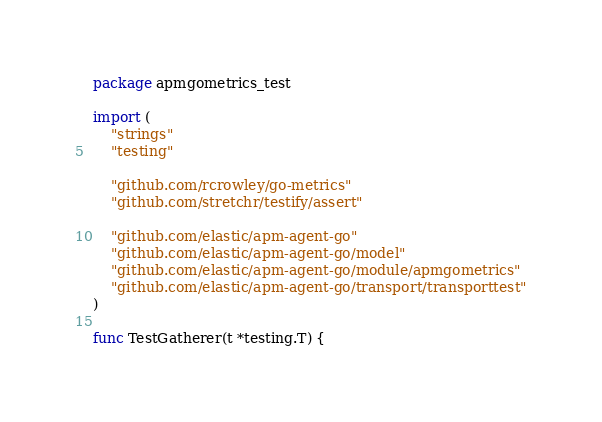Convert code to text. <code><loc_0><loc_0><loc_500><loc_500><_Go_>package apmgometrics_test

import (
	"strings"
	"testing"

	"github.com/rcrowley/go-metrics"
	"github.com/stretchr/testify/assert"

	"github.com/elastic/apm-agent-go"
	"github.com/elastic/apm-agent-go/model"
	"github.com/elastic/apm-agent-go/module/apmgometrics"
	"github.com/elastic/apm-agent-go/transport/transporttest"
)

func TestGatherer(t *testing.T) {</code> 